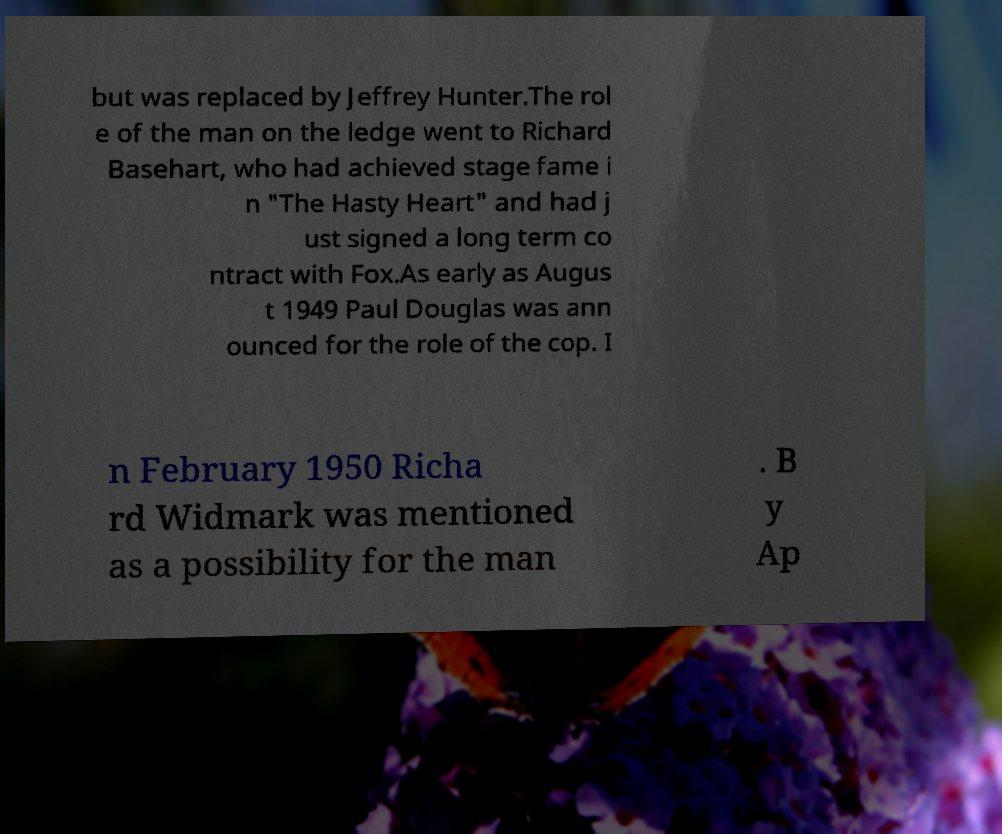Can you accurately transcribe the text from the provided image for me? but was replaced by Jeffrey Hunter.The rol e of the man on the ledge went to Richard Basehart, who had achieved stage fame i n "The Hasty Heart" and had j ust signed a long term co ntract with Fox.As early as Augus t 1949 Paul Douglas was ann ounced for the role of the cop. I n February 1950 Richa rd Widmark was mentioned as a possibility for the man . B y Ap 